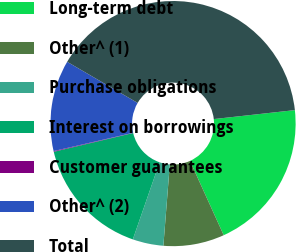<chart> <loc_0><loc_0><loc_500><loc_500><pie_chart><fcel>Long-term debt<fcel>Other^ (1)<fcel>Purchase obligations<fcel>Interest on borrowings<fcel>Customer guarantees<fcel>Other^ (2)<fcel>Total<nl><fcel>19.97%<fcel>8.04%<fcel>4.06%<fcel>15.99%<fcel>0.09%<fcel>12.01%<fcel>39.84%<nl></chart> 